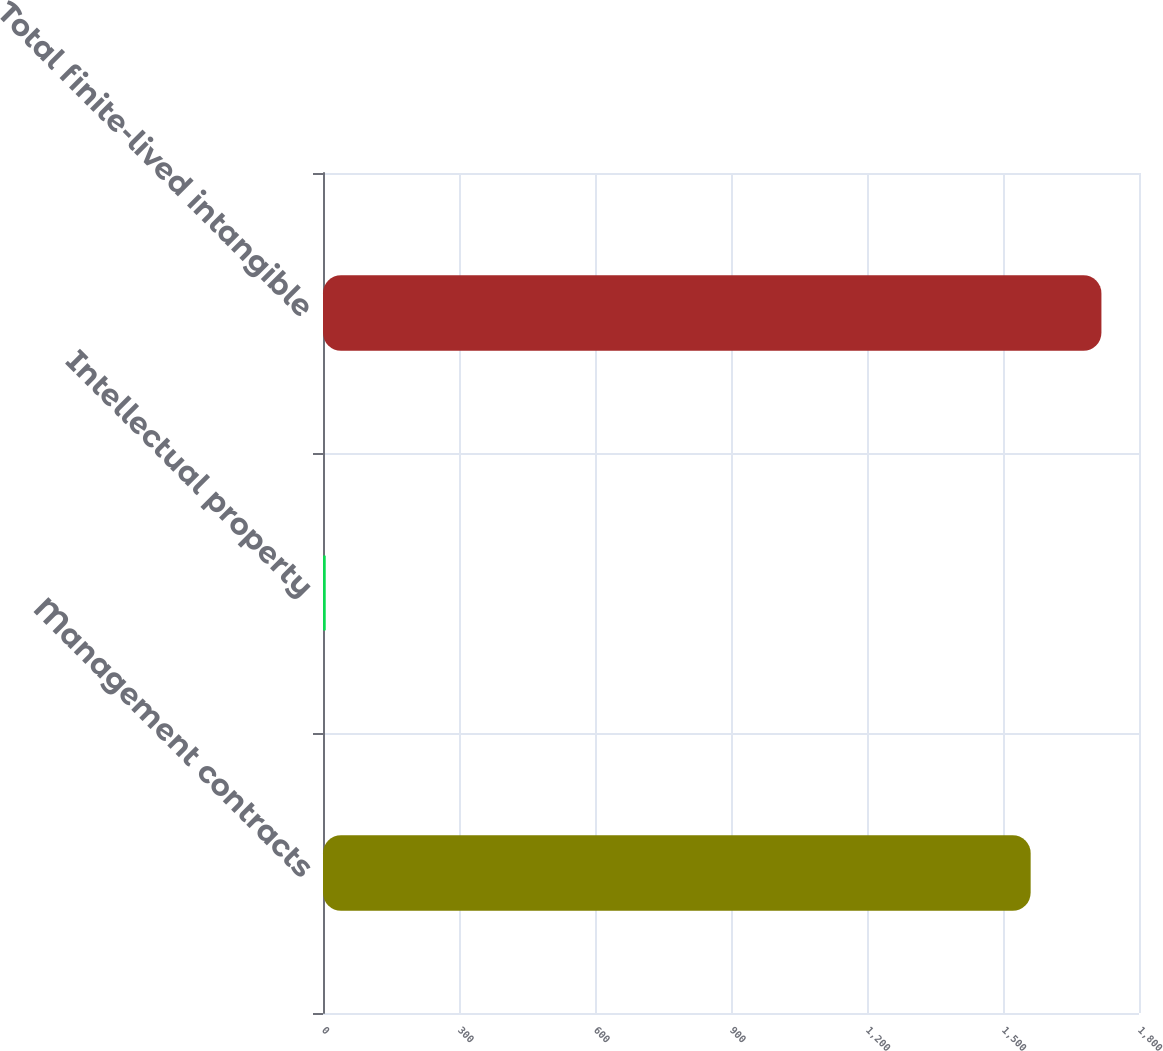Convert chart. <chart><loc_0><loc_0><loc_500><loc_500><bar_chart><fcel>Management contracts<fcel>Intellectual property<fcel>Total finite-lived intangible<nl><fcel>1561<fcel>6<fcel>1717.1<nl></chart> 